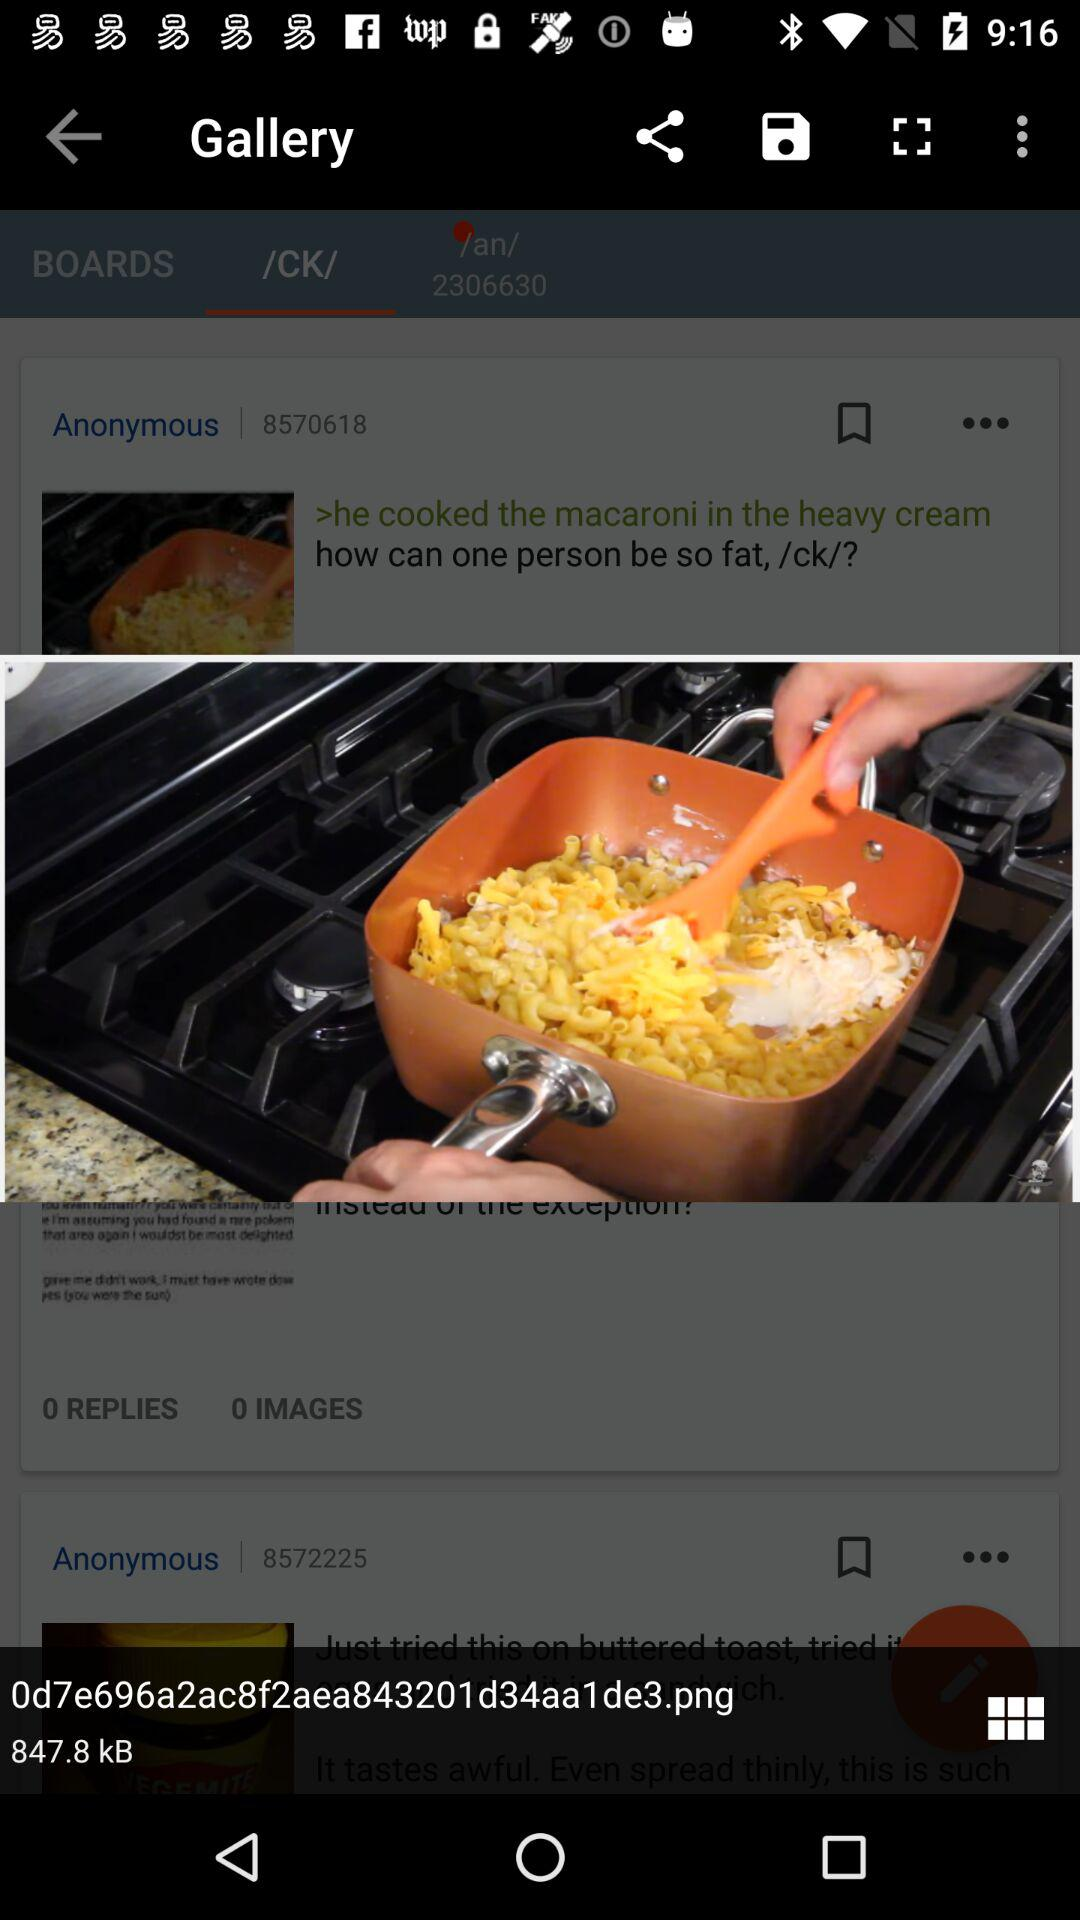What is the size of the image shown on the screen? The size of the image shown on the screen is 847.8 kB. 